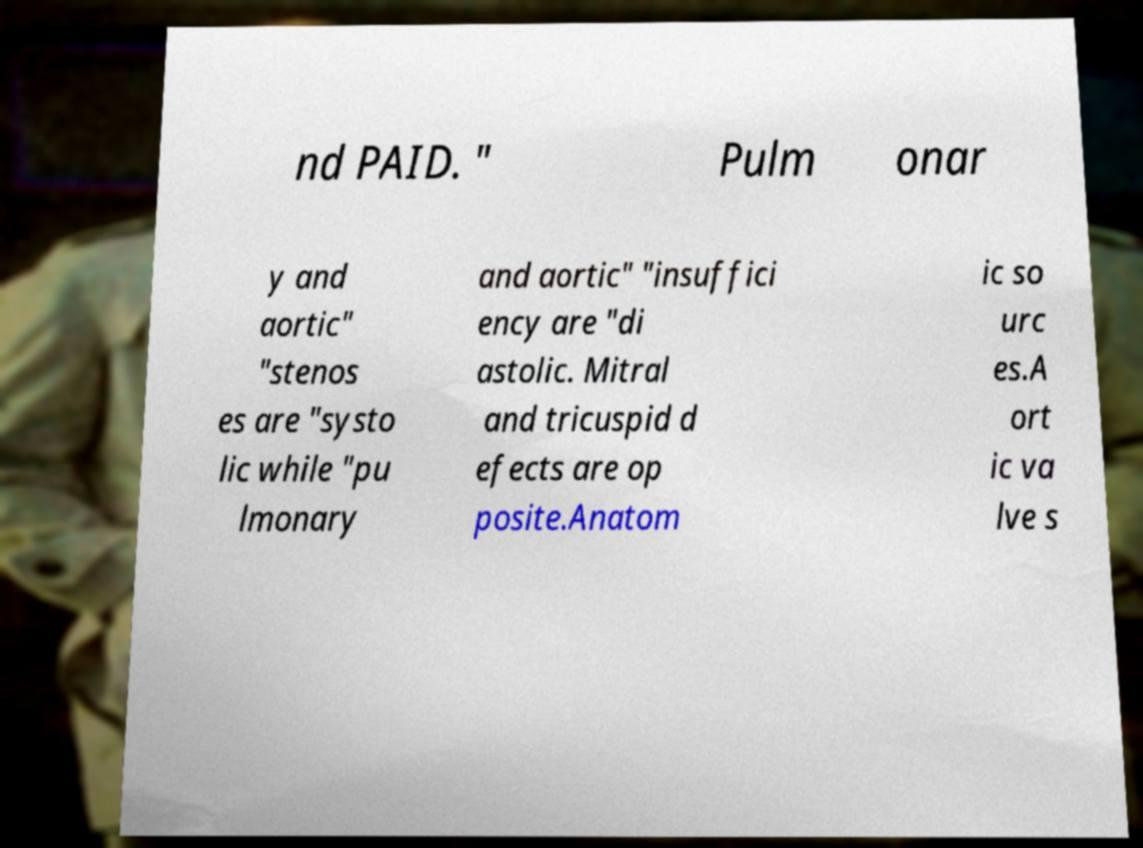What messages or text are displayed in this image? I need them in a readable, typed format. nd PAID. " Pulm onar y and aortic" "stenos es are "systo lic while "pu lmonary and aortic" "insuffici ency are "di astolic. Mitral and tricuspid d efects are op posite.Anatom ic so urc es.A ort ic va lve s 